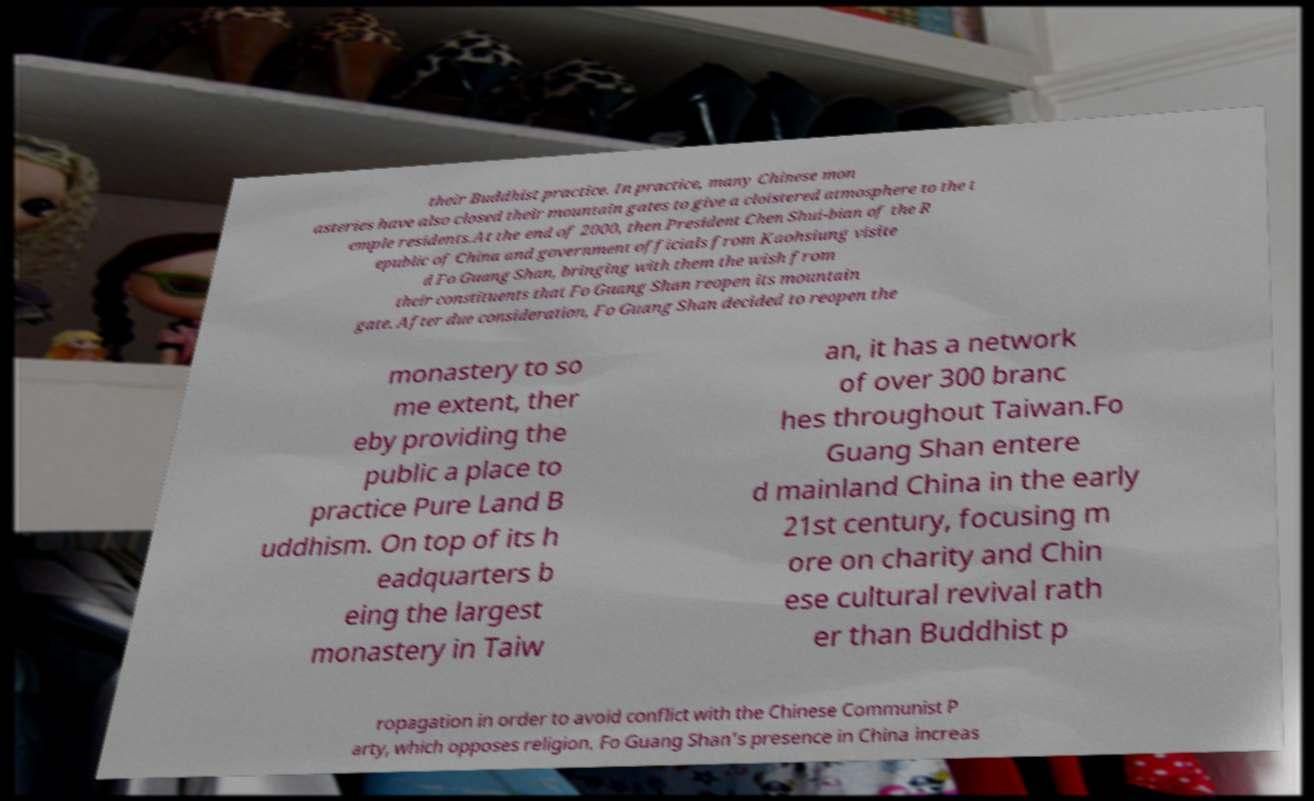Please identify and transcribe the text found in this image. their Buddhist practice. In practice, many Chinese mon asteries have also closed their mountain gates to give a cloistered atmosphere to the t emple residents.At the end of 2000, then President Chen Shui-bian of the R epublic of China and government officials from Kaohsiung visite d Fo Guang Shan, bringing with them the wish from their constituents that Fo Guang Shan reopen its mountain gate. After due consideration, Fo Guang Shan decided to reopen the monastery to so me extent, ther eby providing the public a place to practice Pure Land B uddhism. On top of its h eadquarters b eing the largest monastery in Taiw an, it has a network of over 300 branc hes throughout Taiwan.Fo Guang Shan entere d mainland China in the early 21st century, focusing m ore on charity and Chin ese cultural revival rath er than Buddhist p ropagation in order to avoid conflict with the Chinese Communist P arty, which opposes religion. Fo Guang Shan's presence in China increas 